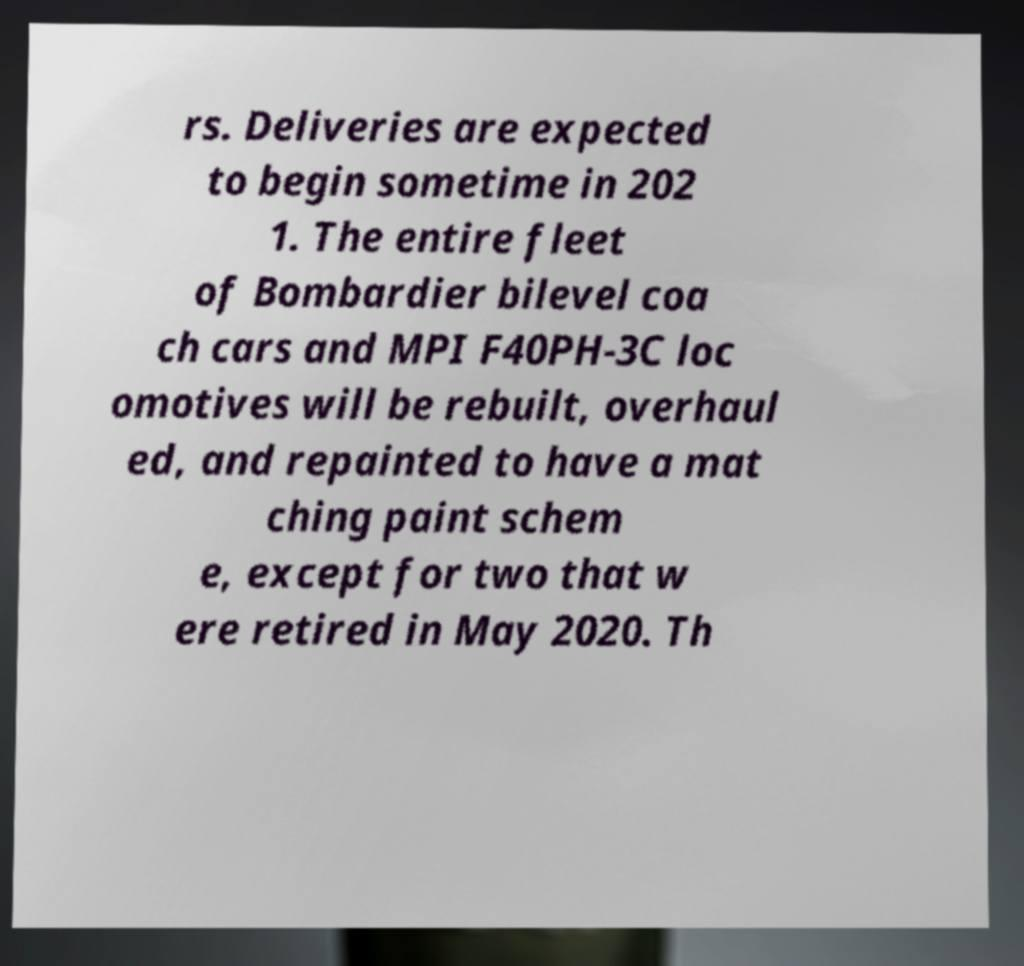There's text embedded in this image that I need extracted. Can you transcribe it verbatim? rs. Deliveries are expected to begin sometime in 202 1. The entire fleet of Bombardier bilevel coa ch cars and MPI F40PH-3C loc omotives will be rebuilt, overhaul ed, and repainted to have a mat ching paint schem e, except for two that w ere retired in May 2020. Th 